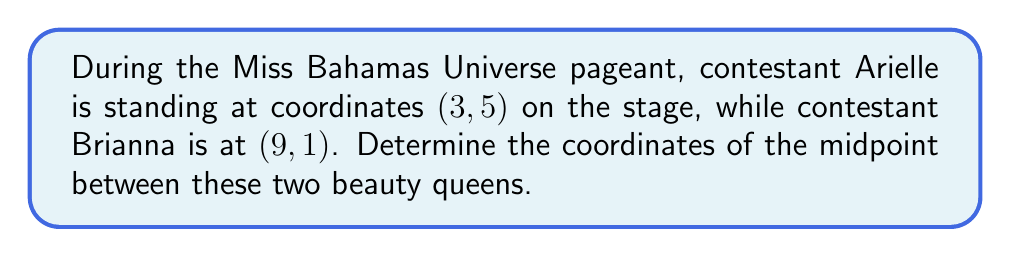Can you answer this question? To find the midpoint between two points, we use the midpoint formula:

$$ \text{Midpoint} = \left(\frac{x_1 + x_2}{2}, \frac{y_1 + y_2}{2}\right) $$

Where $(x_1, y_1)$ are the coordinates of the first point and $(x_2, y_2)$ are the coordinates of the second point.

In this case:
- Arielle's coordinates: $(x_1, y_1) = (3, 5)$
- Brianna's coordinates: $(x_2, y_2) = (9, 1)$

Let's substitute these values into the midpoint formula:

$$ \text{Midpoint} = \left(\frac{3 + 9}{2}, \frac{5 + 1}{2}\right) $$

Now, let's calculate each coordinate:

For the x-coordinate:
$$ \frac{3 + 9}{2} = \frac{12}{2} = 6 $$

For the y-coordinate:
$$ \frac{5 + 1}{2} = \frac{6}{2} = 3 $$

Therefore, the midpoint between Arielle and Brianna on the stage is (6, 3).
Answer: (6, 3) 